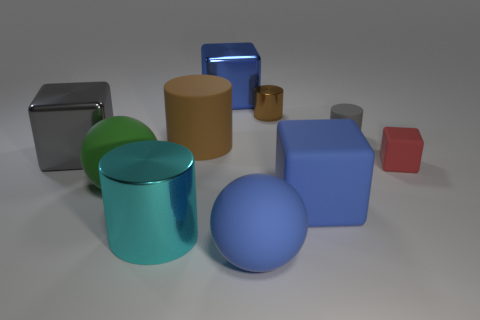What size is the ball behind the big metal thing that is in front of the red rubber object?
Your answer should be very brief. Large. There is a large gray object that is the same shape as the small red matte object; what is its material?
Ensure brevity in your answer.  Metal. How many green rubber objects are there?
Your answer should be compact. 1. There is a rubber sphere that is on the left side of the blue thing in front of the large object that is to the right of the small shiny object; what is its color?
Your answer should be very brief. Green. Are there fewer large blue matte cubes than big rubber objects?
Ensure brevity in your answer.  Yes. There is another large matte object that is the same shape as the green thing; what color is it?
Provide a short and direct response. Blue. There is another cylinder that is made of the same material as the gray cylinder; what is its color?
Your response must be concise. Brown. How many blue blocks have the same size as the red block?
Your response must be concise. 0. What material is the small gray thing?
Offer a very short reply. Rubber. Are there more big green rubber spheres than rubber things?
Offer a very short reply. No. 